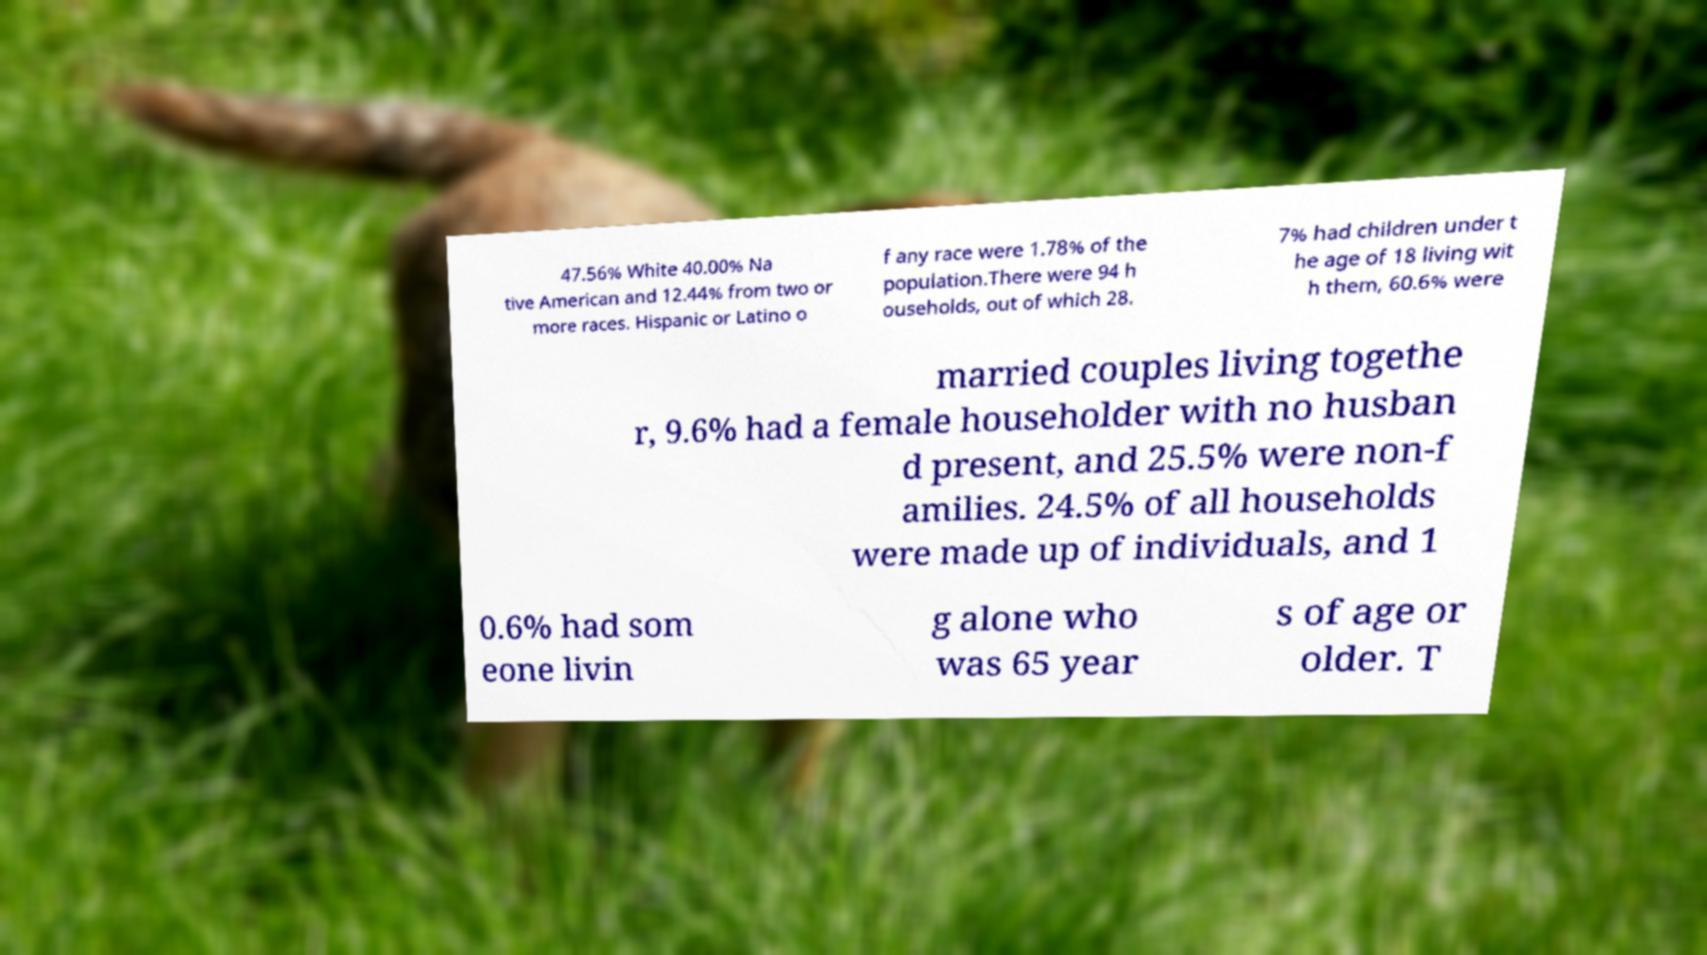What messages or text are displayed in this image? I need them in a readable, typed format. 47.56% White 40.00% Na tive American and 12.44% from two or more races. Hispanic or Latino o f any race were 1.78% of the population.There were 94 h ouseholds, out of which 28. 7% had children under t he age of 18 living wit h them, 60.6% were married couples living togethe r, 9.6% had a female householder with no husban d present, and 25.5% were non-f amilies. 24.5% of all households were made up of individuals, and 1 0.6% had som eone livin g alone who was 65 year s of age or older. T 